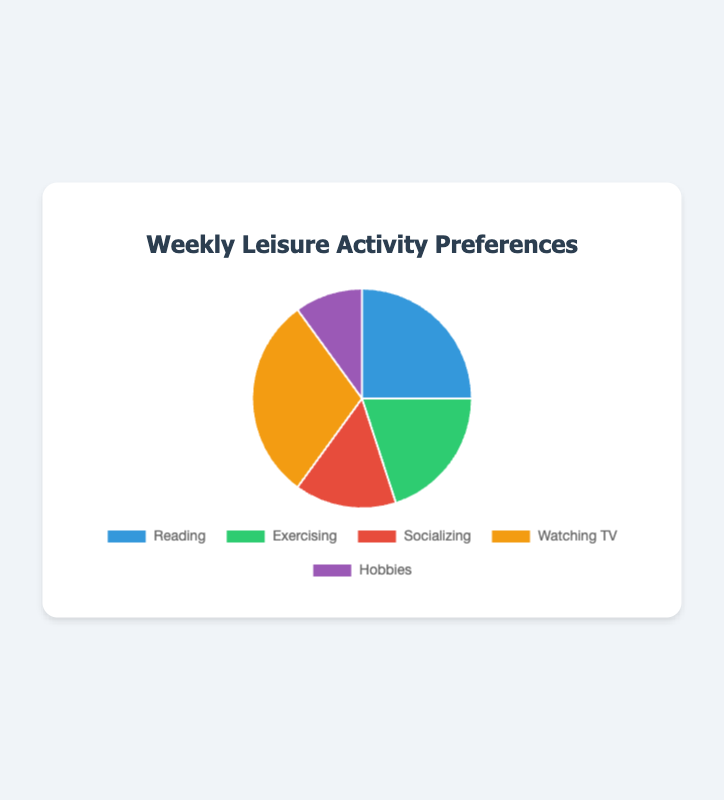What's the most popular weekly leisure activity? The activity with the highest percentage is the most popular one. By looking at the chart, the largest section is for "Watching TV" with 30%.
Answer: Watching TV What's the least popular weekly leisure activity? The activity with the smallest percentage is the least popular one. By looking at the chart, the smallest section is for "Hobbies" with 10%.
Answer: Hobbies How many percentage points more is Watching TV compared to Exercising? To find the difference, subtract the percentage of Exercising from the percentage of Watching TV: 30% - 20% = 10%.
Answer: 10% Which two leisure activities combined constitute exactly 35% of preferences? Sum the percentages of different activities to explore pairs that equal 35%. Reading (25%) + Hobbies (10%) = 35%.
Answer: Reading and Hobbies Which activity's preference is closest to the average preference of all activities? First calculate the average: (25 + 20 + 15 + 30 + 10) / 5 = 20%. The percentage for Exercising is closest to 20%.
Answer: Exercising How much more popular is Reading compared to Socializing? Subtract the percentage for Socializing from the percentage for Reading: 25% - 15% = 10%.
Answer: 10% What is the total percentage of people who prefer Socializing or Exercising as their weekly leisure activity? Sum the percentages for Socializing and Exercising: 15% + 20% = 35%.
Answer: 35% What percentage of people prefer activities other than Watching TV and Reading? Subtract the percentages of Watching TV and Reading from 100%: 100% - (30% + 25%) = 45%.
Answer: 45% What color represents the preference for Exercising in the chart? Identify the color of Exercising in the chart. Exercising is represented by the second color in the dataset which is green.
Answer: Green Is the percentage of people who prefer Reading or Watching TV more than those who prefer Exercising and Socializing combined? Sum the percentages and compare: Reading (25%) + Watching TV (30%) = 55%, Exercising (20%) + Socializing (15%) = 35%. 55% is greater than 35%.
Answer: Yes 